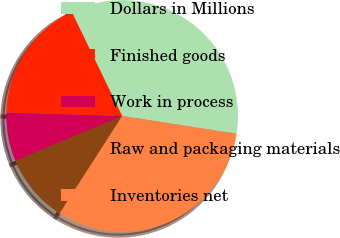Convert chart. <chart><loc_0><loc_0><loc_500><loc_500><pie_chart><fcel>Dollars in Millions<fcel>Finished goods<fcel>Work in process<fcel>Raw and packaging materials<fcel>Inventories net<nl><fcel>34.64%<fcel>17.35%<fcel>6.79%<fcel>9.58%<fcel>31.63%<nl></chart> 